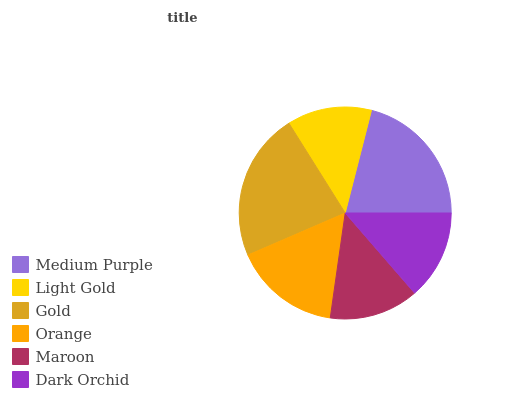Is Light Gold the minimum?
Answer yes or no. Yes. Is Gold the maximum?
Answer yes or no. Yes. Is Gold the minimum?
Answer yes or no. No. Is Light Gold the maximum?
Answer yes or no. No. Is Gold greater than Light Gold?
Answer yes or no. Yes. Is Light Gold less than Gold?
Answer yes or no. Yes. Is Light Gold greater than Gold?
Answer yes or no. No. Is Gold less than Light Gold?
Answer yes or no. No. Is Orange the high median?
Answer yes or no. Yes. Is Dark Orchid the low median?
Answer yes or no. Yes. Is Gold the high median?
Answer yes or no. No. Is Light Gold the low median?
Answer yes or no. No. 